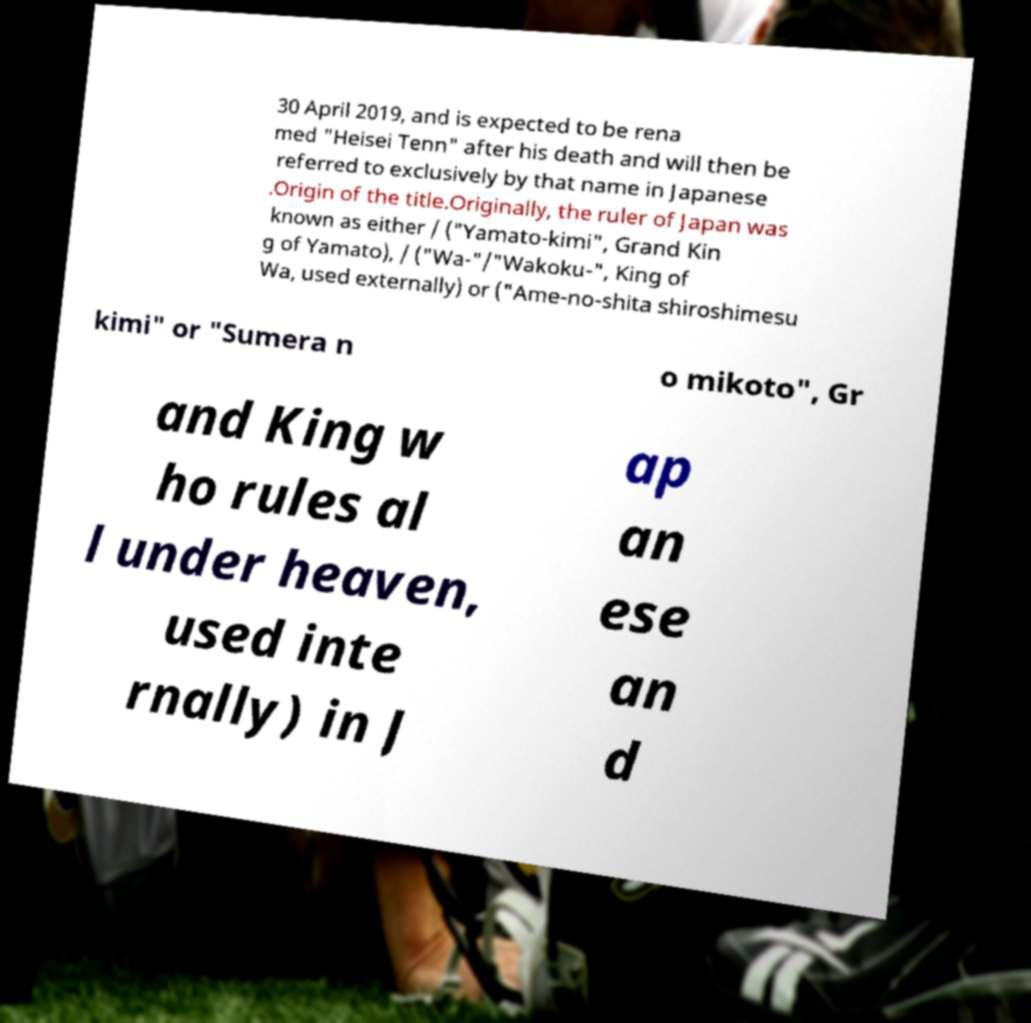Can you read and provide the text displayed in the image?This photo seems to have some interesting text. Can you extract and type it out for me? 30 April 2019, and is expected to be rena med "Heisei Tenn" after his death and will then be referred to exclusively by that name in Japanese .Origin of the title.Originally, the ruler of Japan was known as either / ("Yamato-kimi", Grand Kin g of Yamato), / ("Wa-"/"Wakoku-", King of Wa, used externally) or ("Ame-no-shita shiroshimesu kimi" or "Sumera n o mikoto", Gr and King w ho rules al l under heaven, used inte rnally) in J ap an ese an d 